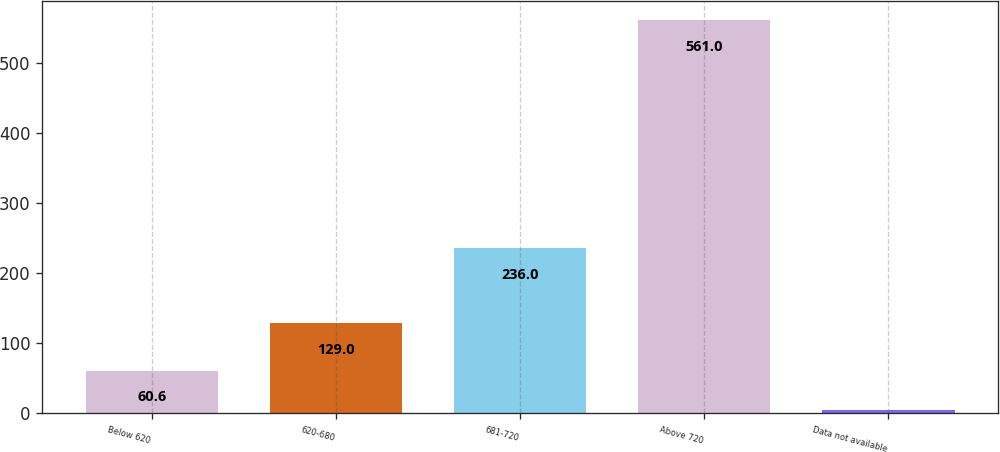<chart> <loc_0><loc_0><loc_500><loc_500><bar_chart><fcel>Below 620<fcel>620-680<fcel>681-720<fcel>Above 720<fcel>Data not available<nl><fcel>60.6<fcel>129<fcel>236<fcel>561<fcel>5<nl></chart> 